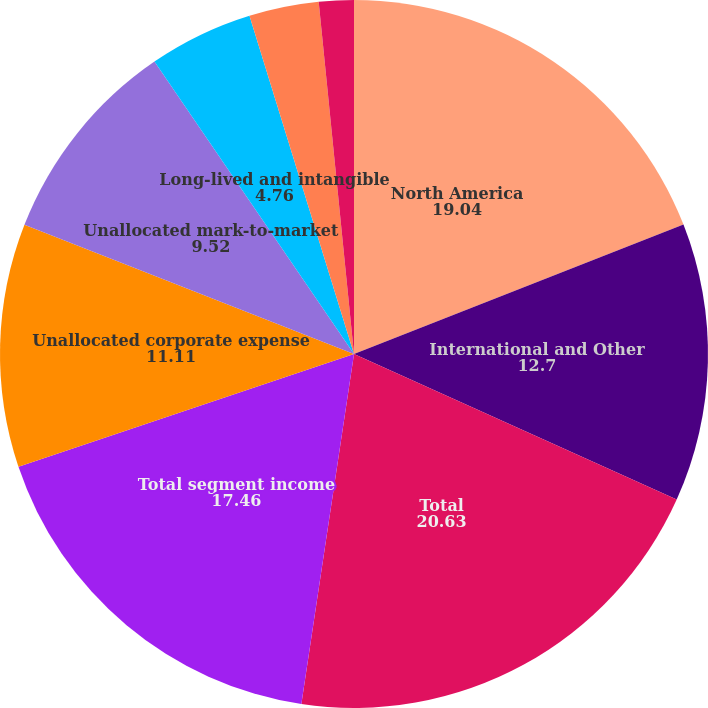Convert chart to OTSL. <chart><loc_0><loc_0><loc_500><loc_500><pie_chart><fcel>For the years ended December<fcel>North America<fcel>International and Other<fcel>Total<fcel>Total segment income<fcel>Unallocated corporate expense<fcel>Unallocated mark-to-market<fcel>Long-lived and intangible<fcel>Costs associated with business<fcel>Acquisition-related costs<nl><fcel>0.0%<fcel>19.04%<fcel>12.7%<fcel>20.63%<fcel>17.46%<fcel>11.11%<fcel>9.52%<fcel>4.76%<fcel>3.18%<fcel>1.59%<nl></chart> 